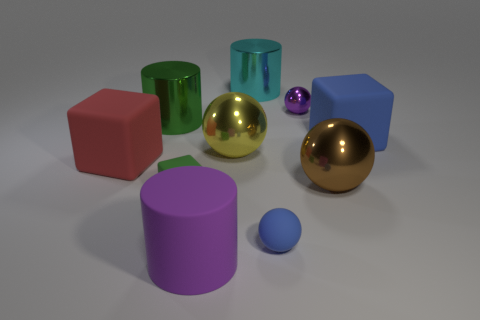Are there any objects that stand out due to their color? Yes, the large red cube stands out due to its vibrant color in contrast to the cooler hues of the other objects in the scene. 